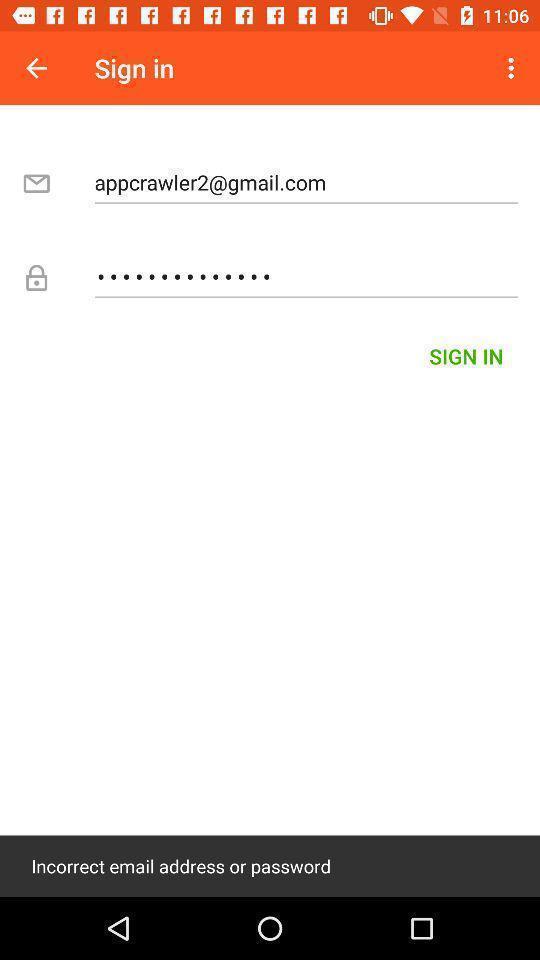Provide a detailed account of this screenshot. Sign in page. 